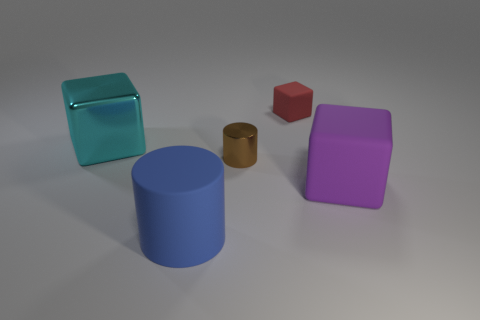The object that is the same size as the brown cylinder is what shape?
Give a very brief answer. Cube. What shape is the blue object that is the same material as the tiny cube?
Make the answer very short. Cylinder. Is there anything else that has the same shape as the large blue rubber thing?
Provide a short and direct response. Yes. Is the material of the big object to the right of the brown thing the same as the small brown cylinder?
Make the answer very short. No. There is a large thing that is in front of the large purple matte block; what is its material?
Make the answer very short. Rubber. What size is the rubber thing behind the big block in front of the small brown metallic cylinder?
Your answer should be compact. Small. What number of cyan shiny things are the same size as the purple thing?
Offer a very short reply. 1. There is a metallic thing that is on the right side of the large blue matte thing; is its color the same as the big cube that is on the right side of the small rubber block?
Provide a short and direct response. No. There is a small red matte thing; are there any cyan things in front of it?
Your response must be concise. Yes. What color is the big thing that is both on the left side of the small red thing and in front of the big cyan metallic thing?
Your response must be concise. Blue. 